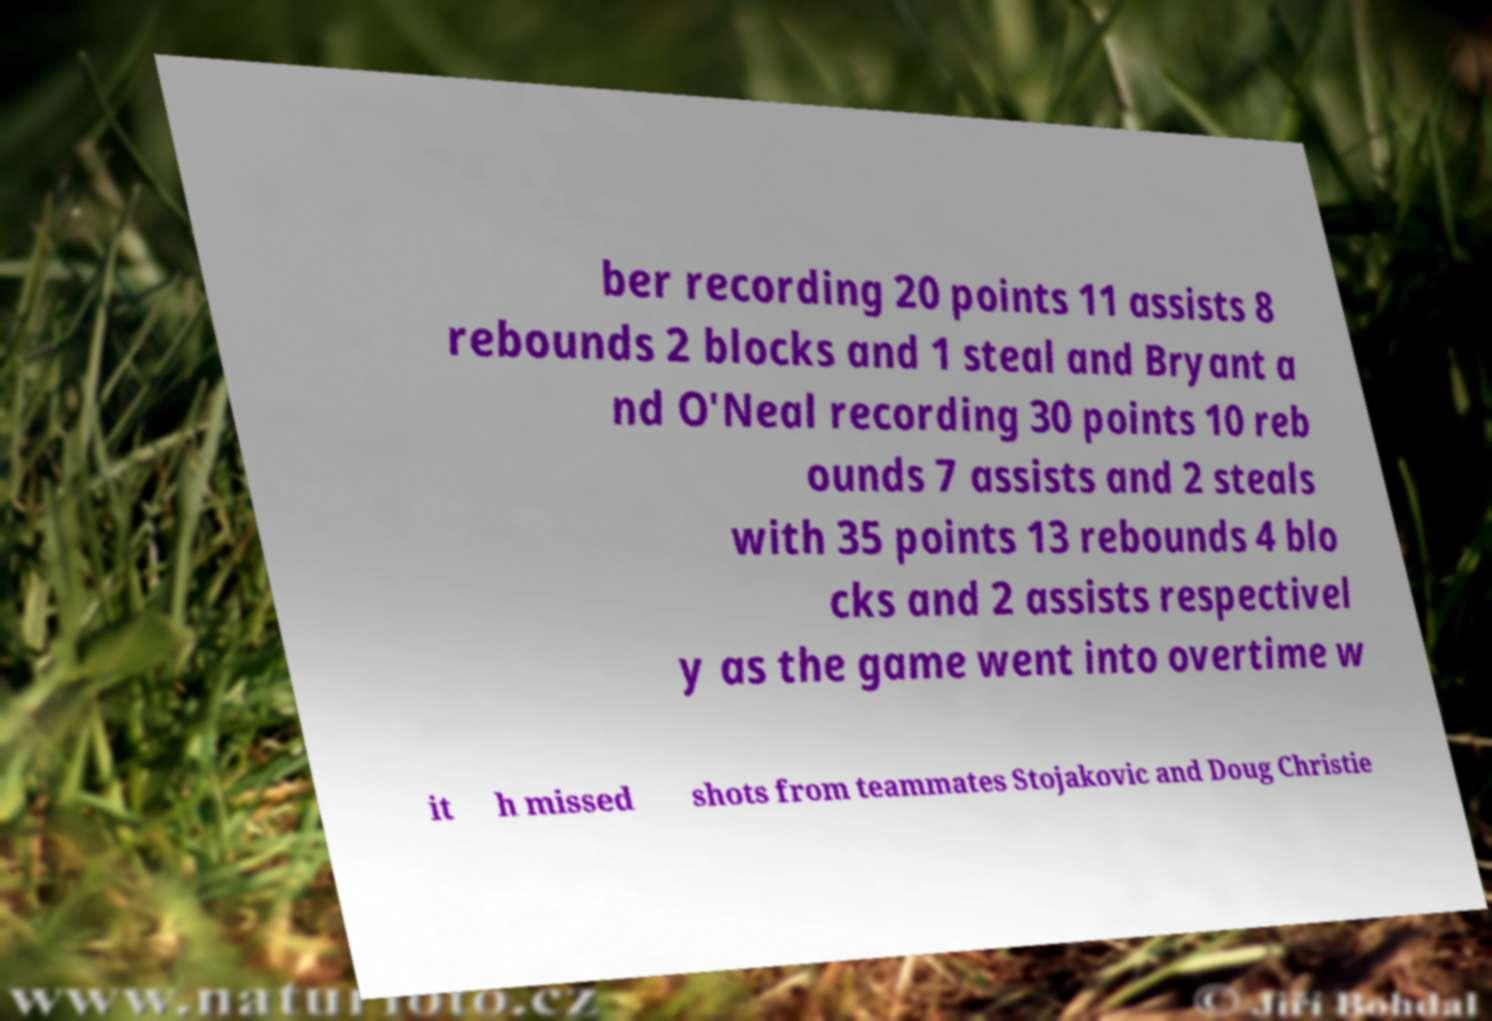Can you read and provide the text displayed in the image?This photo seems to have some interesting text. Can you extract and type it out for me? ber recording 20 points 11 assists 8 rebounds 2 blocks and 1 steal and Bryant a nd O'Neal recording 30 points 10 reb ounds 7 assists and 2 steals with 35 points 13 rebounds 4 blo cks and 2 assists respectivel y as the game went into overtime w it h missed shots from teammates Stojakovic and Doug Christie 